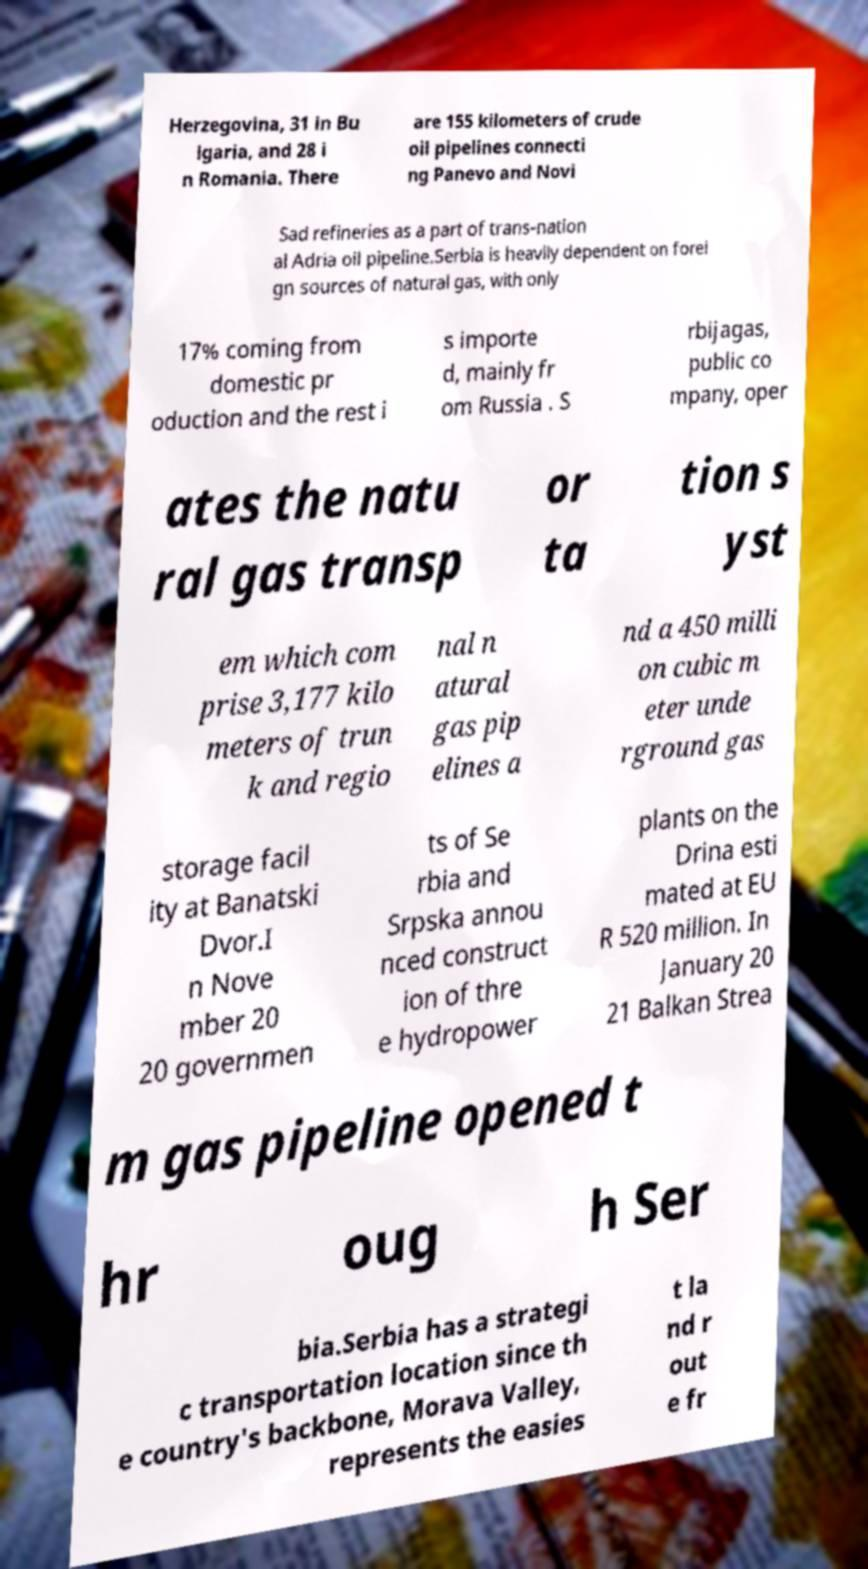For documentation purposes, I need the text within this image transcribed. Could you provide that? Herzegovina, 31 in Bu lgaria, and 28 i n Romania. There are 155 kilometers of crude oil pipelines connecti ng Panevo and Novi Sad refineries as a part of trans-nation al Adria oil pipeline.Serbia is heavily dependent on forei gn sources of natural gas, with only 17% coming from domestic pr oduction and the rest i s importe d, mainly fr om Russia . S rbijagas, public co mpany, oper ates the natu ral gas transp or ta tion s yst em which com prise 3,177 kilo meters of trun k and regio nal n atural gas pip elines a nd a 450 milli on cubic m eter unde rground gas storage facil ity at Banatski Dvor.I n Nove mber 20 20 governmen ts of Se rbia and Srpska annou nced construct ion of thre e hydropower plants on the Drina esti mated at EU R 520 million. In January 20 21 Balkan Strea m gas pipeline opened t hr oug h Ser bia.Serbia has a strategi c transportation location since th e country's backbone, Morava Valley, represents the easies t la nd r out e fr 